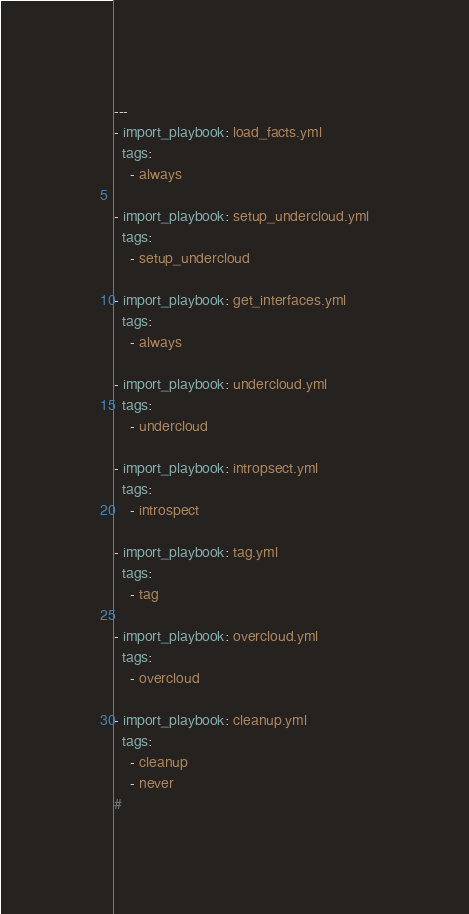<code> <loc_0><loc_0><loc_500><loc_500><_YAML_>---
- import_playbook: load_facts.yml
  tags:
    - always

- import_playbook: setup_undercloud.yml
  tags:
    - setup_undercloud

- import_playbook: get_interfaces.yml
  tags:
    - always

- import_playbook: undercloud.yml
  tags:
    - undercloud

- import_playbook: intropsect.yml
  tags:
    - introspect

- import_playbook: tag.yml
  tags:
    - tag

- import_playbook: overcloud.yml
  tags:
    - overcloud

- import_playbook: cleanup.yml
  tags:
    - cleanup
    - never
#
</code> 